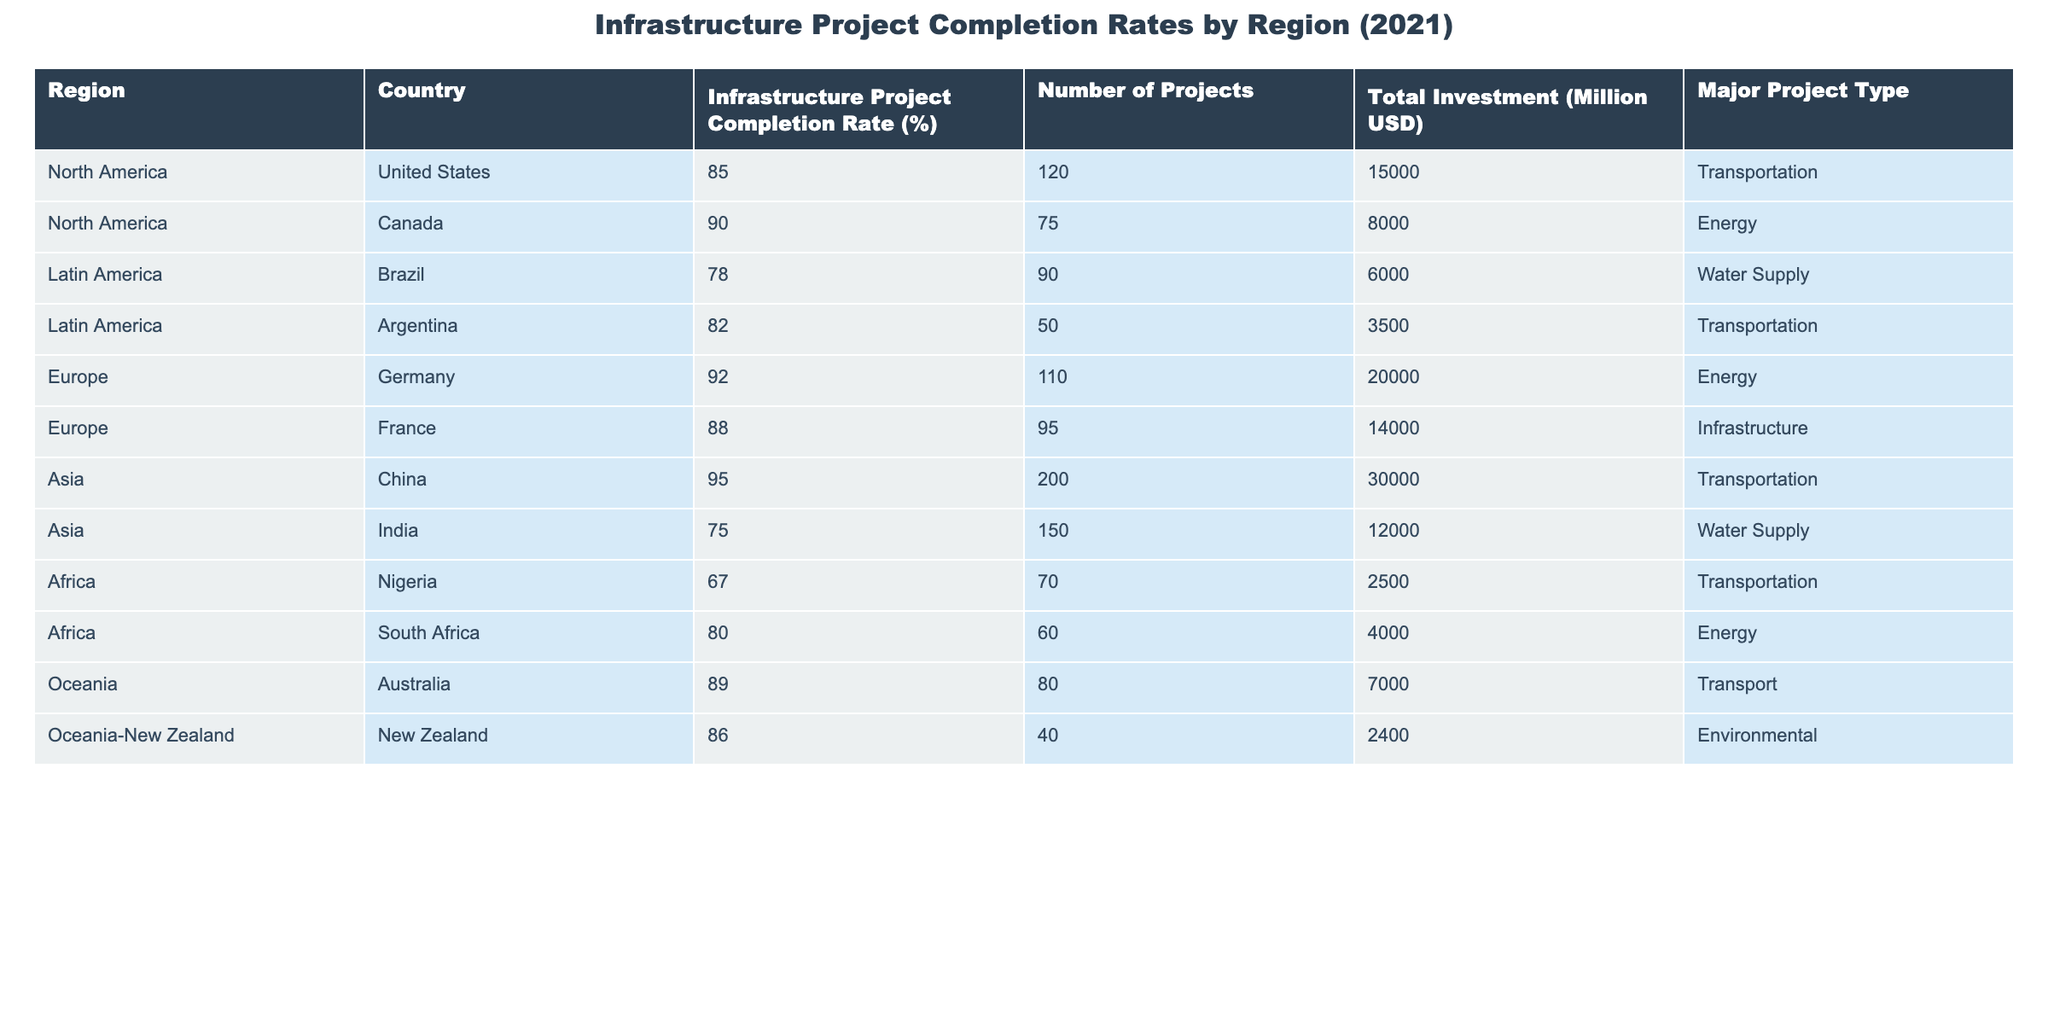What is the infrastructure project completion rate in Canada? The table clearly lists Canada with a completion rate of 90%.
Answer: 90% Which country has the highest infrastructure project completion rate? According to the table, China has the highest completion rate at 95%.
Answer: 95% How many infrastructure projects were completed in Nigeria? The table states that Nigeria completed 70 infrastructure projects.
Answer: 70 What is the total investment in infrastructure projects in Europe? In the table, the total investment for Europe can be calculated by adding Germany's 20000 million USD and France's 14000 million USD, resulting in 34000 million USD.
Answer: 34000 million USD Is the completion rate in India higher than that in Brazil? The table shows India's completion rate at 75% and Brazil's at 78%. Thus, India's rate is not higher.
Answer: No What is the difference in completion rates between North America and Africa? North America's average completion rate is (85+90)/2 = 87.5%, and Africa’s average is (67+80)/2 = 73.5%. The difference is 87.5% - 73.5% = 14%.
Answer: 14% How many total infrastructure projects were completed in Latin America? Summing the number of projects in Brazil (90) and Argentina (50) gives a total of 140 projects completed in Latin America.
Answer: 140 Which region has the lowest average infrastructure project completion rate? Calculating averages: North America (87.5%), Latin America (80%), Europe (90%), Asia (85%), Africa (73.5%), and Oceania (87.5%). Thus, Africa has the lowest average completion rate at 73.5%.
Answer: Africa What is the major project type for the country with the highest total investment? China has the highest total investment of 30000 million USD, with the major project type being Transportation.
Answer: Transportation Are there more projects completed in North America than in Oceania? North America has 195 projects (120 in the United States + 75 in Canada), while Oceania has 120 projects (80 in Australia + 40 in New Zealand). So, yes, North America has more projects completed than Oceania.
Answer: Yes 